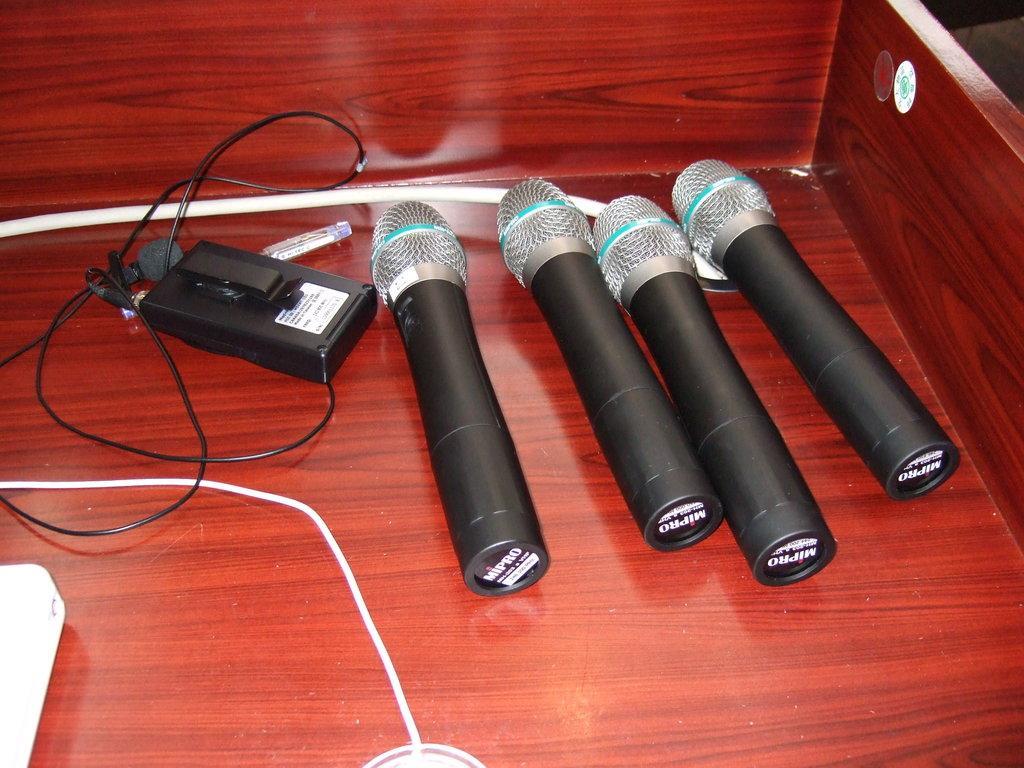Describe this image in one or two sentences. There are four mics and a electronic device with wires on a wooden surface. 